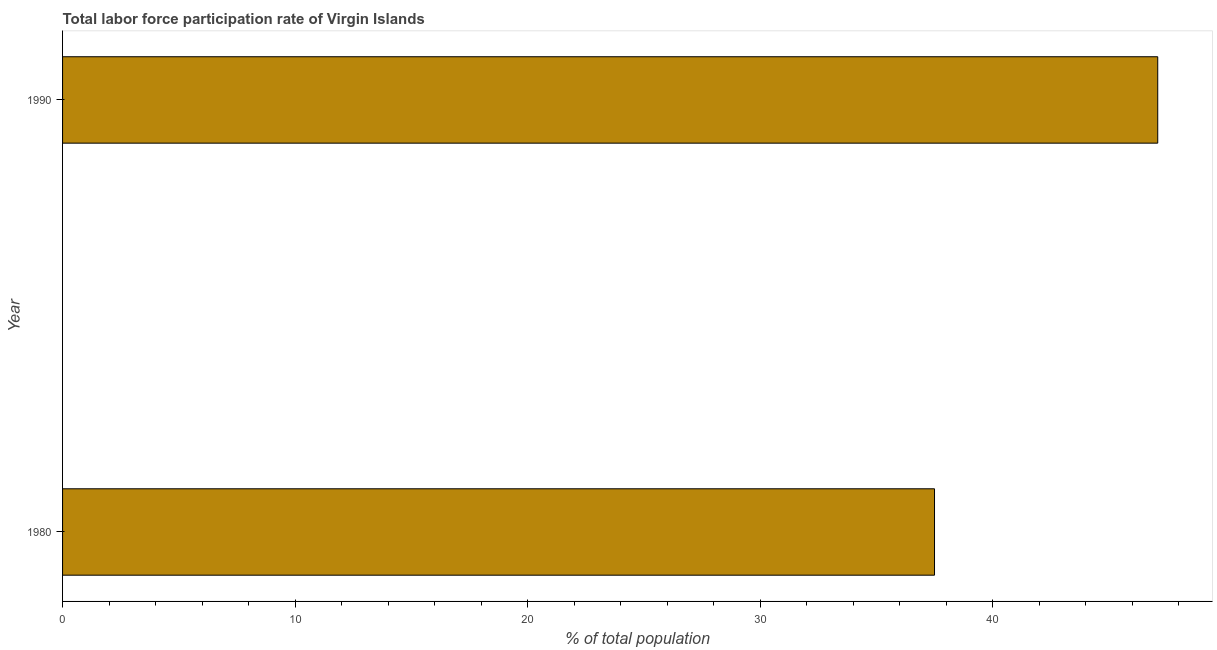What is the title of the graph?
Provide a short and direct response. Total labor force participation rate of Virgin Islands. What is the label or title of the X-axis?
Offer a terse response. % of total population. What is the label or title of the Y-axis?
Your answer should be very brief. Year. What is the total labor force participation rate in 1990?
Keep it short and to the point. 47.1. Across all years, what is the maximum total labor force participation rate?
Make the answer very short. 47.1. Across all years, what is the minimum total labor force participation rate?
Keep it short and to the point. 37.5. What is the sum of the total labor force participation rate?
Offer a terse response. 84.6. What is the average total labor force participation rate per year?
Make the answer very short. 42.3. What is the median total labor force participation rate?
Give a very brief answer. 42.3. In how many years, is the total labor force participation rate greater than 30 %?
Offer a terse response. 2. What is the ratio of the total labor force participation rate in 1980 to that in 1990?
Make the answer very short. 0.8. Is the total labor force participation rate in 1980 less than that in 1990?
Keep it short and to the point. Yes. How many bars are there?
Make the answer very short. 2. Are all the bars in the graph horizontal?
Provide a succinct answer. Yes. Are the values on the major ticks of X-axis written in scientific E-notation?
Your answer should be very brief. No. What is the % of total population in 1980?
Your answer should be compact. 37.5. What is the % of total population of 1990?
Your answer should be very brief. 47.1. What is the ratio of the % of total population in 1980 to that in 1990?
Give a very brief answer. 0.8. 